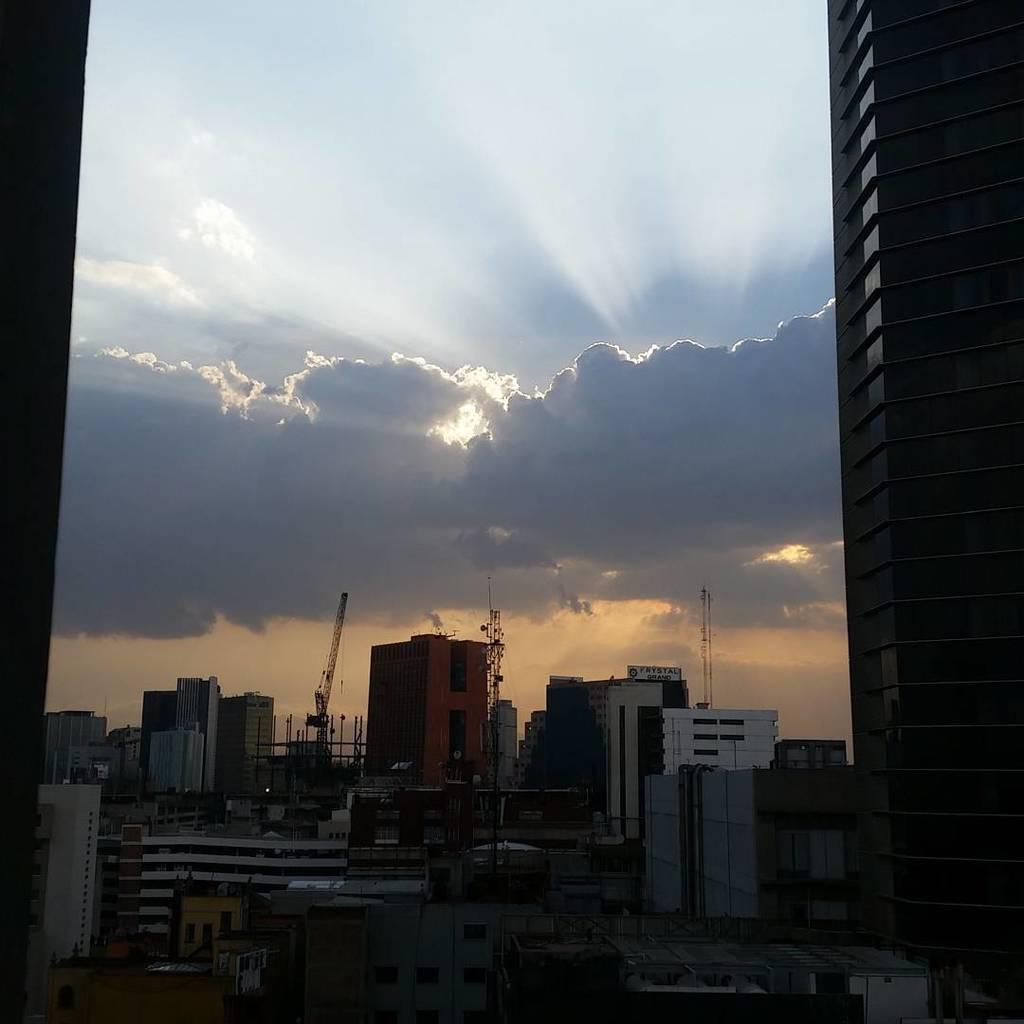In one or two sentences, can you explain what this image depicts? In this image I can see few buildings,windows and cranes. The sky is in blue and white color. 